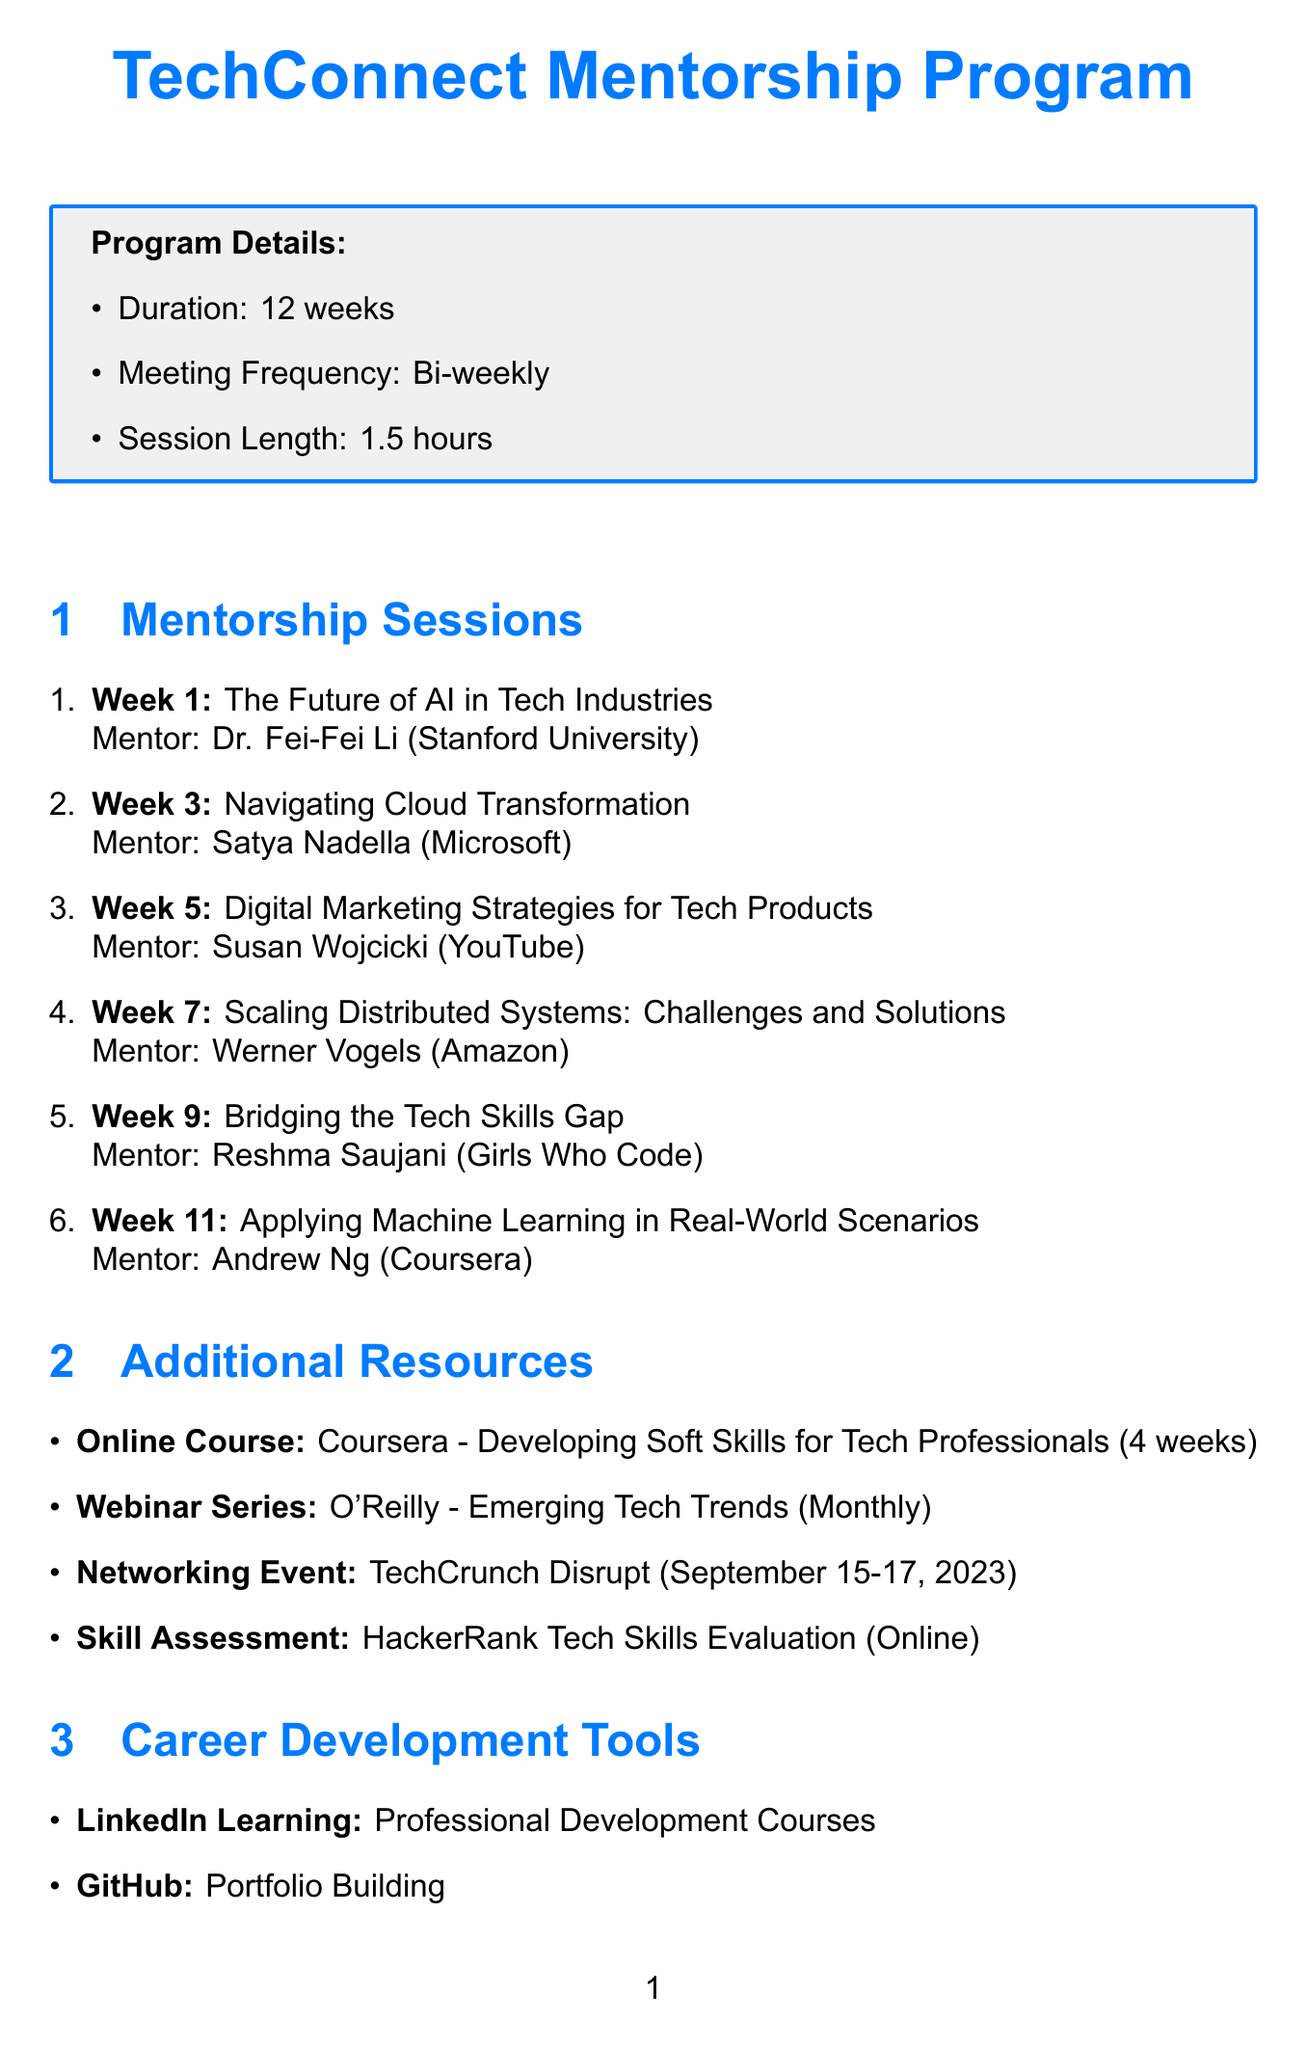What is the duration of the TechConnect Mentorship Program? The duration of the program is stated to be 12 weeks.
Answer: 12 weeks Who is the mentor for the session on "Digital Marketing Strategies for Tech Products"? The document specifies that Susan Wojcicki is the mentor for that session.
Answer: Susan Wojcicki How many mentorship sessions are scheduled in total? By counting the listed sessions, there are six mentorship sessions.
Answer: 6 What topic will be discussed in week 9? The document lists that the topic for week 9 is "Bridging the Tech Skills Gap."
Answer: Bridging the Tech Skills Gap What is the session length for each meeting? The program details mention that each session will last 1.5 hours.
Answer: 1.5 hours What type of additional resource includes a skill assessment? The document indicates that "HackerRank Tech Skills Evaluation" is a skill assessment.
Answer: HackerRank Tech Skills Evaluation Who is the mentor associated with "Scaling Distributed Systems: Challenges and Solutions"? The document states that Werner Vogels is the mentor for that session.
Answer: Werner Vogels What is the frequency of the "Emerging Tech Trends" webinar series? The document specifies that the frequency of this webinar series is monthly.
Answer: Monthly 